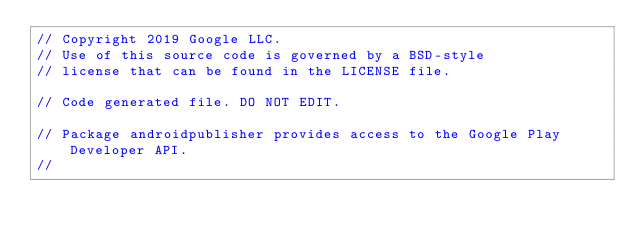Convert code to text. <code><loc_0><loc_0><loc_500><loc_500><_Go_>// Copyright 2019 Google LLC.
// Use of this source code is governed by a BSD-style
// license that can be found in the LICENSE file.

// Code generated file. DO NOT EDIT.

// Package androidpublisher provides access to the Google Play Developer API.
//</code> 